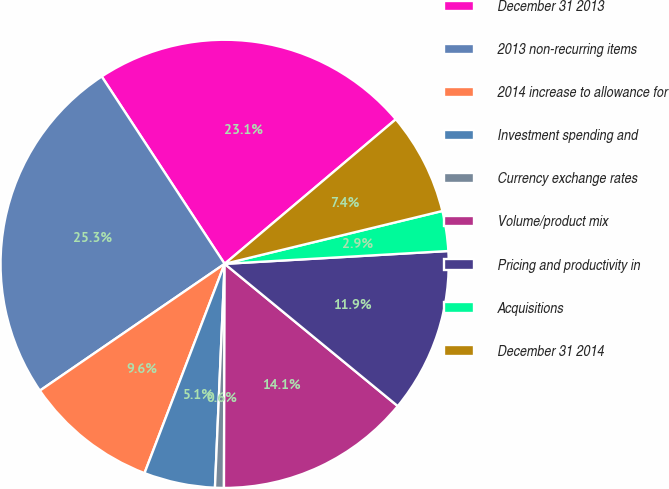Convert chart. <chart><loc_0><loc_0><loc_500><loc_500><pie_chart><fcel>December 31 2013<fcel>2013 non-recurring items<fcel>2014 increase to allowance for<fcel>Investment spending and<fcel>Currency exchange rates<fcel>Volume/product mix<fcel>Pricing and productivity in<fcel>Acquisitions<fcel>December 31 2014<nl><fcel>23.08%<fcel>25.33%<fcel>9.61%<fcel>5.13%<fcel>0.64%<fcel>14.1%<fcel>11.86%<fcel>2.88%<fcel>7.37%<nl></chart> 